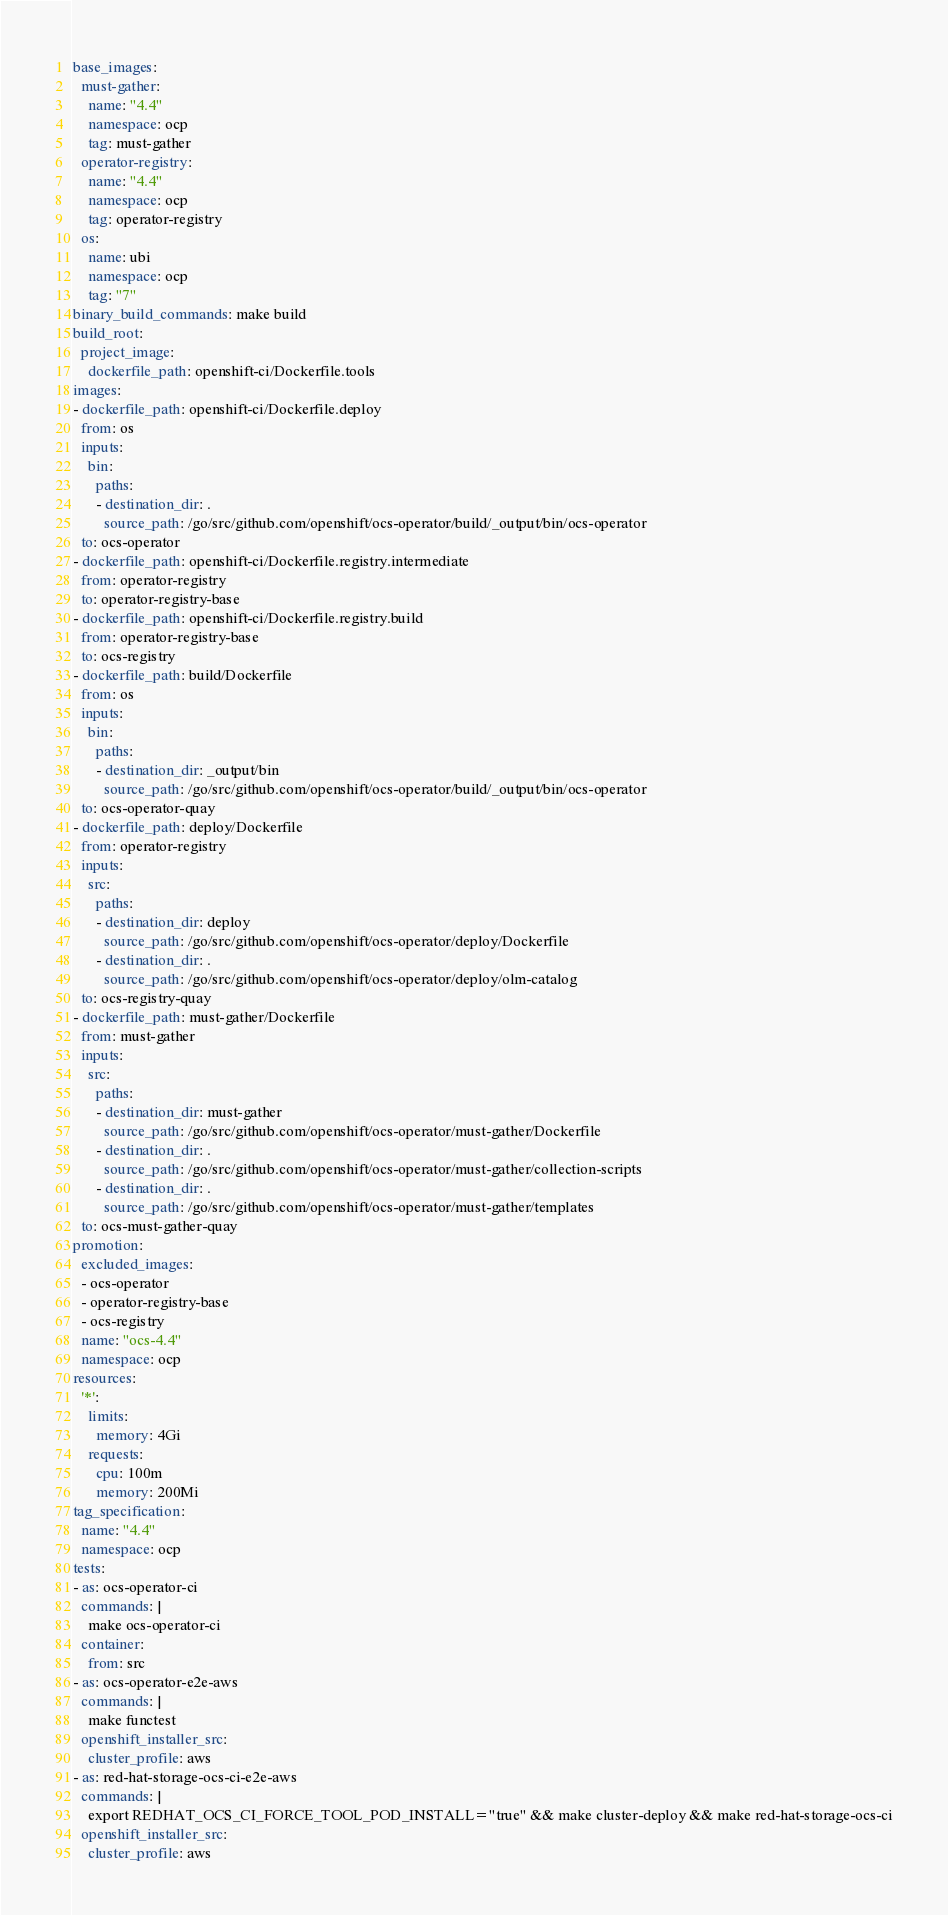Convert code to text. <code><loc_0><loc_0><loc_500><loc_500><_YAML_>base_images:
  must-gather:
    name: "4.4"
    namespace: ocp
    tag: must-gather
  operator-registry:
    name: "4.4"
    namespace: ocp
    tag: operator-registry
  os:
    name: ubi
    namespace: ocp
    tag: "7"
binary_build_commands: make build
build_root:
  project_image:
    dockerfile_path: openshift-ci/Dockerfile.tools
images:
- dockerfile_path: openshift-ci/Dockerfile.deploy
  from: os
  inputs:
    bin:
      paths:
      - destination_dir: .
        source_path: /go/src/github.com/openshift/ocs-operator/build/_output/bin/ocs-operator
  to: ocs-operator
- dockerfile_path: openshift-ci/Dockerfile.registry.intermediate
  from: operator-registry
  to: operator-registry-base
- dockerfile_path: openshift-ci/Dockerfile.registry.build
  from: operator-registry-base
  to: ocs-registry
- dockerfile_path: build/Dockerfile
  from: os
  inputs:
    bin:
      paths:
      - destination_dir: _output/bin
        source_path: /go/src/github.com/openshift/ocs-operator/build/_output/bin/ocs-operator
  to: ocs-operator-quay
- dockerfile_path: deploy/Dockerfile
  from: operator-registry
  inputs:
    src:
      paths:
      - destination_dir: deploy
        source_path: /go/src/github.com/openshift/ocs-operator/deploy/Dockerfile
      - destination_dir: .
        source_path: /go/src/github.com/openshift/ocs-operator/deploy/olm-catalog
  to: ocs-registry-quay
- dockerfile_path: must-gather/Dockerfile
  from: must-gather
  inputs:
    src:
      paths:
      - destination_dir: must-gather
        source_path: /go/src/github.com/openshift/ocs-operator/must-gather/Dockerfile
      - destination_dir: .
        source_path: /go/src/github.com/openshift/ocs-operator/must-gather/collection-scripts
      - destination_dir: .
        source_path: /go/src/github.com/openshift/ocs-operator/must-gather/templates
  to: ocs-must-gather-quay
promotion:
  excluded_images:
  - ocs-operator
  - operator-registry-base
  - ocs-registry
  name: "ocs-4.4"
  namespace: ocp
resources:
  '*':
    limits:
      memory: 4Gi
    requests:
      cpu: 100m
      memory: 200Mi
tag_specification:
  name: "4.4"
  namespace: ocp
tests:
- as: ocs-operator-ci
  commands: |
    make ocs-operator-ci
  container:
    from: src
- as: ocs-operator-e2e-aws
  commands: |
    make functest
  openshift_installer_src:
    cluster_profile: aws
- as: red-hat-storage-ocs-ci-e2e-aws
  commands: |
    export REDHAT_OCS_CI_FORCE_TOOL_POD_INSTALL="true" && make cluster-deploy && make red-hat-storage-ocs-ci
  openshift_installer_src:
    cluster_profile: aws
</code> 